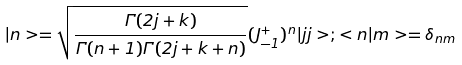<formula> <loc_0><loc_0><loc_500><loc_500>| n > = \sqrt { \frac { \Gamma ( 2 j + k ) } { \Gamma ( n + 1 ) \Gamma ( 2 j + k + n ) } } ( J _ { - 1 } ^ { + } ) ^ { n } | j j > ; < n | m > = \delta _ { n m }</formula> 